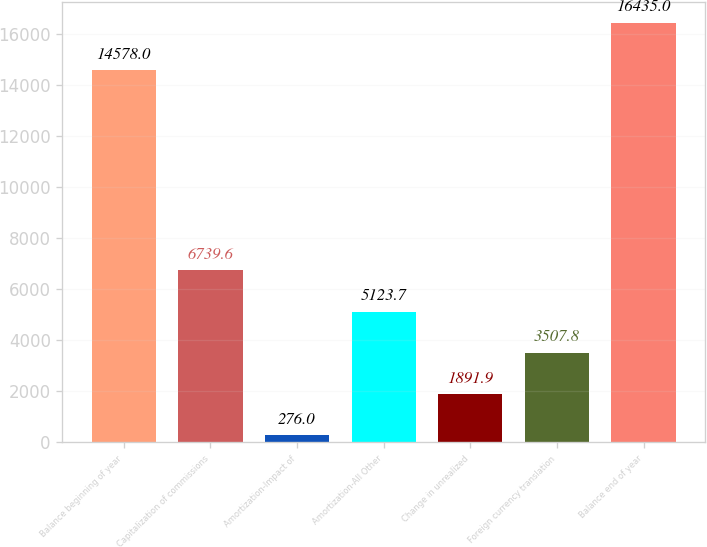Convert chart to OTSL. <chart><loc_0><loc_0><loc_500><loc_500><bar_chart><fcel>Balance beginning of year<fcel>Capitalization of commissions<fcel>Amortization-Impact of<fcel>Amortization-All Other<fcel>Change in unrealized<fcel>Foreign currency translation<fcel>Balance end of year<nl><fcel>14578<fcel>6739.6<fcel>276<fcel>5123.7<fcel>1891.9<fcel>3507.8<fcel>16435<nl></chart> 